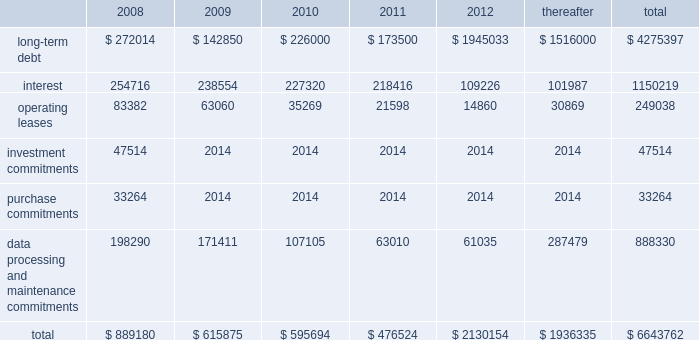Our existing cash flow hedges are highly effective and there is no current impact on earnings due to hedge ineffectiveness .
It is our policy to execute such instruments with credit-worthy banks and not to enter into derivative financial instruments for speculative purposes .
Contractual obligations fis 2019s long-term contractual obligations generally include its long-term debt and operating lease payments on certain of its property and equipment .
The table summarizes fis 2019s significant contractual obligations and commitments as of december 31 , 2007 ( in thousands ) : .
Off-balance sheet arrangements fis does not have any material off-balance sheet arrangements other than operating leases .
Escrow arrangements in conducting our title agency , closing and 1031 exchange services operations , we routinely hold customers 2019 assets in escrow , pending completion of real estate transactions .
Certain of these amounts are maintained in segregated bank accounts and have not been included in the accompanying consolidated balance sheets .
We have a contingent liability relating to proper disposition of these balances , which amounted to $ 1926.8 million at december 31 , 2007 .
As a result of holding these customers 2019 assets in escrow , we have ongoing programs for realizing economic benefits during the year through favorable borrowing and vendor arrangements with various banks .
There were no loans outstanding as of december 31 , 2007 and these balances were invested in short term , high grade investments that minimize the risk to principal .
Recent accounting pronouncements in december 2007 , the fasb issued sfas no .
141 ( revised 2007 ) , business combinations ( 201csfas 141 ( r ) 201d ) , requiring an acquirer in a business combination to recognize the assets acquired , the liabilities assumed , and any noncontrolling interest in the acquiree at their fair values at the acquisition date , with limited exceptions .
The costs of the acquisition and any related restructuring costs will be recognized separately .
Assets and liabilities arising from contingencies in a business combination are to be recognized at their fair value at the acquisition date and adjusted prospectively as new information becomes available .
When the fair value of assets acquired exceeds the fair value of consideration transferred plus any noncontrolling interest in the acquiree , the excess will be recognized as a gain .
Under sfas 141 ( r ) , all business combinations will be accounted for by applying the acquisition method , including combinations among mutual entities and combinations by contract alone .
Sfas 141 ( r ) applies prospectively to business combinations for which the acquisition date is on or after the first annual reporting period beginning on or after december 15 , 2008 , is effective for periods beginning on or after december 15 , 2008 , and will apply to business combinations occurring after the effective date .
Management is currently evaluating the impact of this statement on our statements of financial position and operations .
In december 2007 , the fasb issued sfas no .
160 , noncontrolling interests in consolidated financial statements 2014 an amendment of arb no .
51 ( 201csfas 160 201d ) , requiring noncontrolling interests ( sometimes called minority interests ) to be presented as a component of equity on the balance sheet .
Sfas 160 also requires that the amount of net income attributable to the parent and to the noncontrolling interests be clearly identified and presented on the face of the consolidated statement of income .
This statement eliminates the need to apply purchase .
What percentage of total significant contractual obligations and commitments as of december 31 , 2007 are is interest? 
Computations: (1150219 / 6643762)
Answer: 0.17313. 